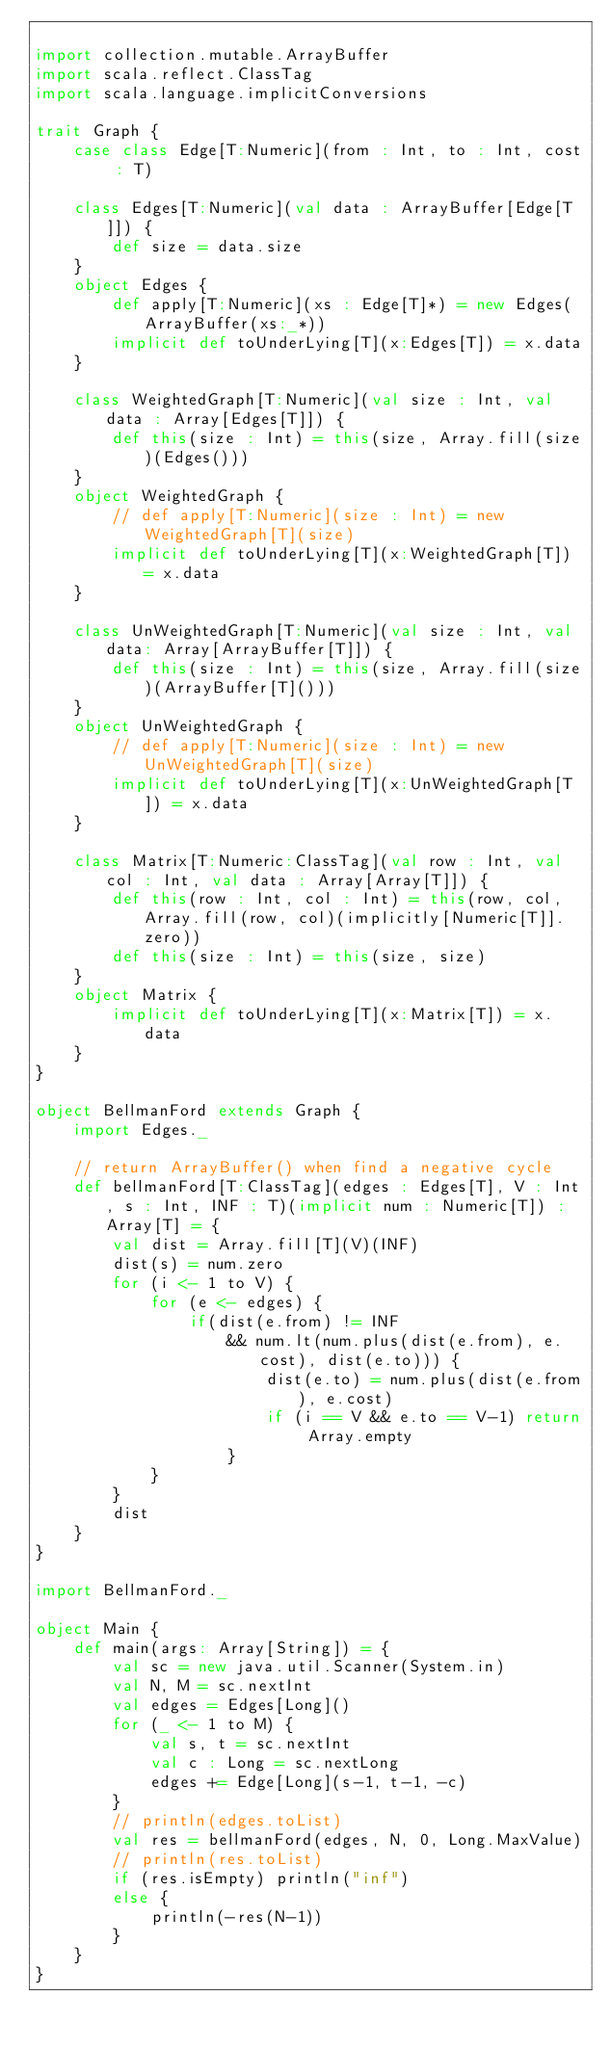Convert code to text. <code><loc_0><loc_0><loc_500><loc_500><_Scala_>
import collection.mutable.ArrayBuffer
import scala.reflect.ClassTag
import scala.language.implicitConversions

trait Graph { 
    case class Edge[T:Numeric](from : Int, to : Int, cost : T)

    class Edges[T:Numeric](val data : ArrayBuffer[Edge[T]]) {
        def size = data.size
    }
    object Edges {
        def apply[T:Numeric](xs : Edge[T]*) = new Edges(ArrayBuffer(xs:_*))
        implicit def toUnderLying[T](x:Edges[T]) = x.data
    }

    class WeightedGraph[T:Numeric](val size : Int, val data : Array[Edges[T]]) {
        def this(size : Int) = this(size, Array.fill(size)(Edges()))
    }
    object WeightedGraph {
        // def apply[T:Numeric](size : Int) = new WeightedGraph[T](size)
        implicit def toUnderLying[T](x:WeightedGraph[T]) = x.data
    }

    class UnWeightedGraph[T:Numeric](val size : Int, val data: Array[ArrayBuffer[T]]) {
        def this(size : Int) = this(size, Array.fill(size)(ArrayBuffer[T]()))
    }
    object UnWeightedGraph {
        // def apply[T:Numeric](size : Int) = new UnWeightedGraph[T](size)
        implicit def toUnderLying[T](x:UnWeightedGraph[T]) = x.data
    }
   
    class Matrix[T:Numeric:ClassTag](val row : Int, val col : Int, val data : Array[Array[T]]) {
        def this(row : Int, col : Int) = this(row, col, Array.fill(row, col)(implicitly[Numeric[T]].zero))
        def this(size : Int) = this(size, size)
    }
    object Matrix {
        implicit def toUnderLying[T](x:Matrix[T]) = x.data
    }
}

object BellmanFord extends Graph {
    import Edges._

    // return ArrayBuffer() when find a negative cycle
    def bellmanFord[T:ClassTag](edges : Edges[T], V : Int, s : Int, INF : T)(implicit num : Numeric[T]) : Array[T] = {
        val dist = Array.fill[T](V)(INF)
        dist(s) = num.zero
        for (i <- 1 to V) {
            for (e <- edges) {
                if(dist(e.from) != INF 
                    && num.lt(num.plus(dist(e.from), e.cost), dist(e.to))) {
                        dist(e.to) = num.plus(dist(e.from), e.cost)
                        if (i == V && e.to == V-1) return Array.empty
                    }
            }
        }
        dist
    }
}

import BellmanFord._

object Main {
    def main(args: Array[String]) = {
        val sc = new java.util.Scanner(System.in)
        val N, M = sc.nextInt
        val edges = Edges[Long]()
        for (_ <- 1 to M) {
            val s, t = sc.nextInt
            val c : Long = sc.nextLong
            edges += Edge[Long](s-1, t-1, -c)
        }
        // println(edges.toList)
        val res = bellmanFord(edges, N, 0, Long.MaxValue)
        // println(res.toList)
        if (res.isEmpty) println("inf")
        else {
            println(-res(N-1))
        }
    }
}</code> 